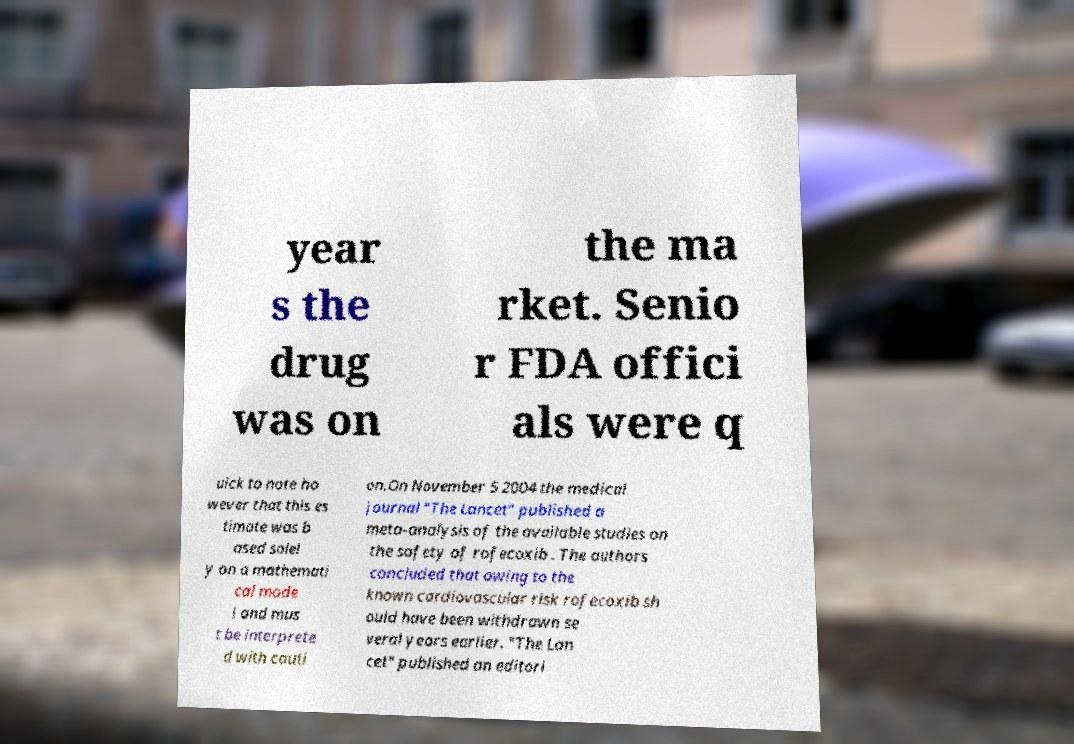For documentation purposes, I need the text within this image transcribed. Could you provide that? year s the drug was on the ma rket. Senio r FDA offici als were q uick to note ho wever that this es timate was b ased solel y on a mathemati cal mode l and mus t be interprete d with cauti on.On November 5 2004 the medical journal "The Lancet" published a meta-analysis of the available studies on the safety of rofecoxib . The authors concluded that owing to the known cardiovascular risk rofecoxib sh ould have been withdrawn se veral years earlier. "The Lan cet" published an editori 